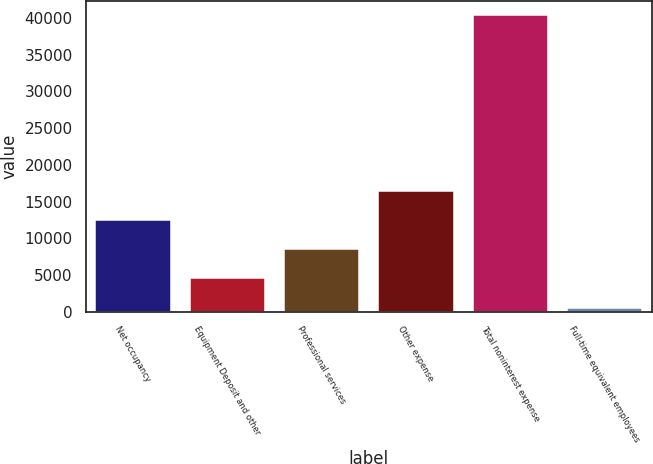<chart> <loc_0><loc_0><loc_500><loc_500><bar_chart><fcel>Net occupancy<fcel>Equipment Deposit and other<fcel>Professional services<fcel>Other expense<fcel>Total noninterest expense<fcel>Full-time equivalent employees<nl><fcel>12498.9<fcel>4540.3<fcel>8519.6<fcel>16478.2<fcel>40354<fcel>561<nl></chart> 